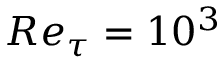Convert formula to latex. <formula><loc_0><loc_0><loc_500><loc_500>R e _ { \tau } = 1 0 ^ { 3 }</formula> 